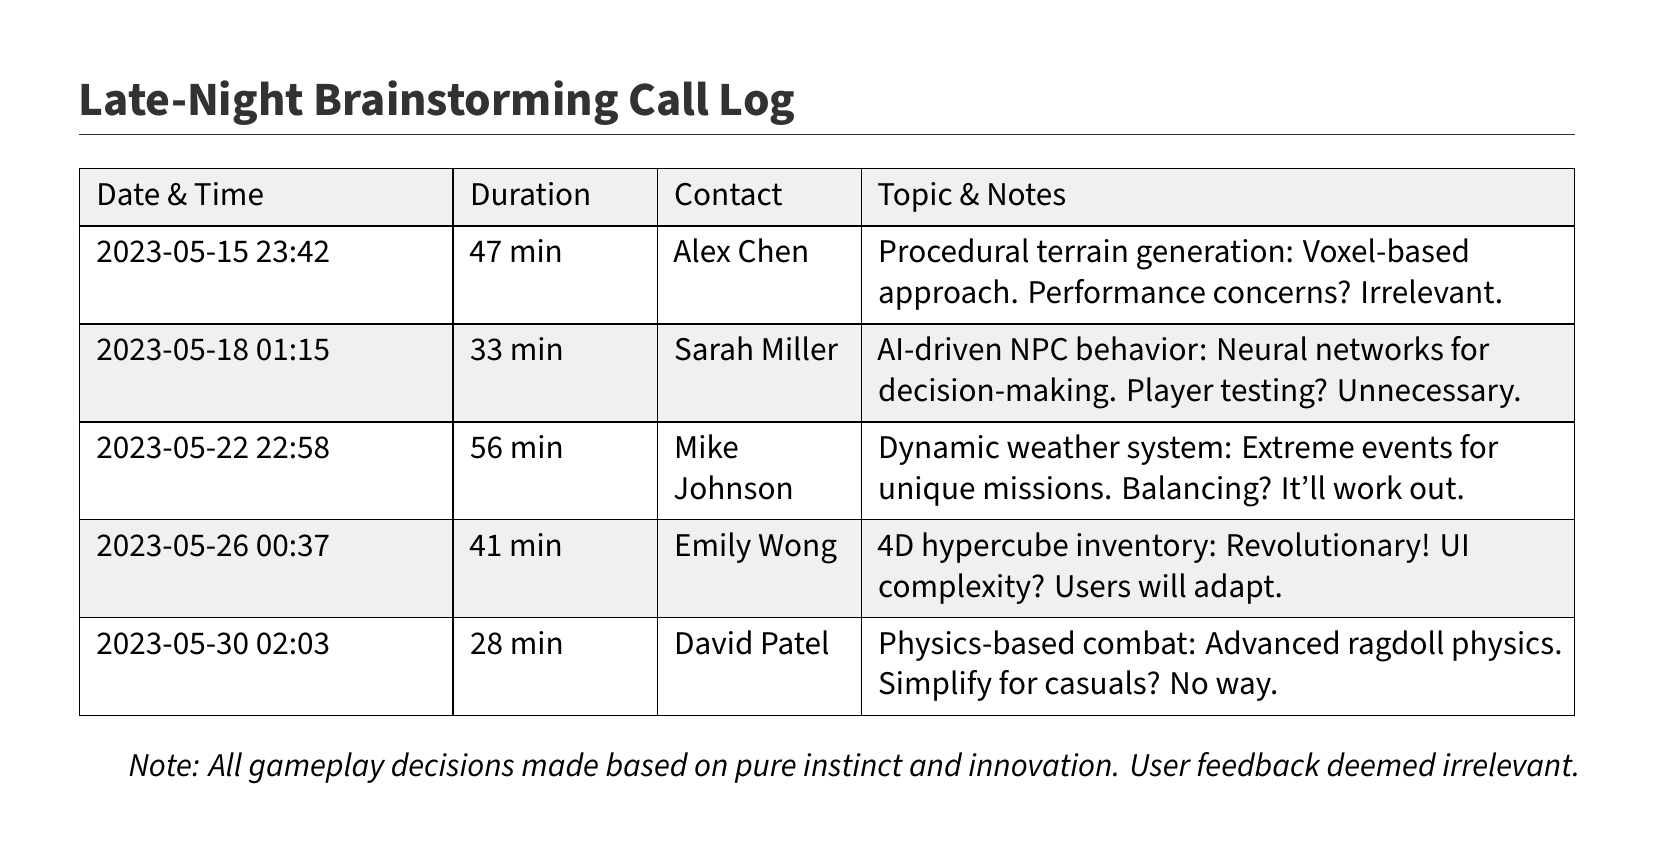what was the duration of the call with Alex Chen? The duration of the call is listed in the document for each contact. For Alex Chen, it is 47 min.
Answer: 47 min who discussed AI-driven NPC behavior? The document lists the name of the contact associated with each topic. Sarah Miller discussed AI-driven NPC behavior.
Answer: Sarah Miller how many minutes did the call with Emily Wong last? Each call duration is specified in the document. The call with Emily Wong lasted 41 min.
Answer: 41 min on what date was the call about procedural terrain generation? The document provides the date along with each topic. The call about procedural terrain generation was on 2023-05-15.
Answer: 2023-05-15 what is the main topic of the call with Mike Johnson? The topic for each call is stated clearly. Mike Johnson discussed a dynamic weather system.
Answer: Dynamic weather system what was the opinion on player testing for AI-driven NPC behavior? The notes provide insights into the discussions for each topic. The opinion was that player testing is unnecessary.
Answer: Unnecessary what time was the call regarding the 4D hypercube inventory? The document specifies the time for each call. The call regarding the 4D hypercube inventory was at 00:37.
Answer: 00:37 how does the creator feel about user feedback based on this document? The document concludes with a note, indicating the creator's stance regarding user feedback. They deemed user feedback irrelevant.
Answer: Irrelevant 